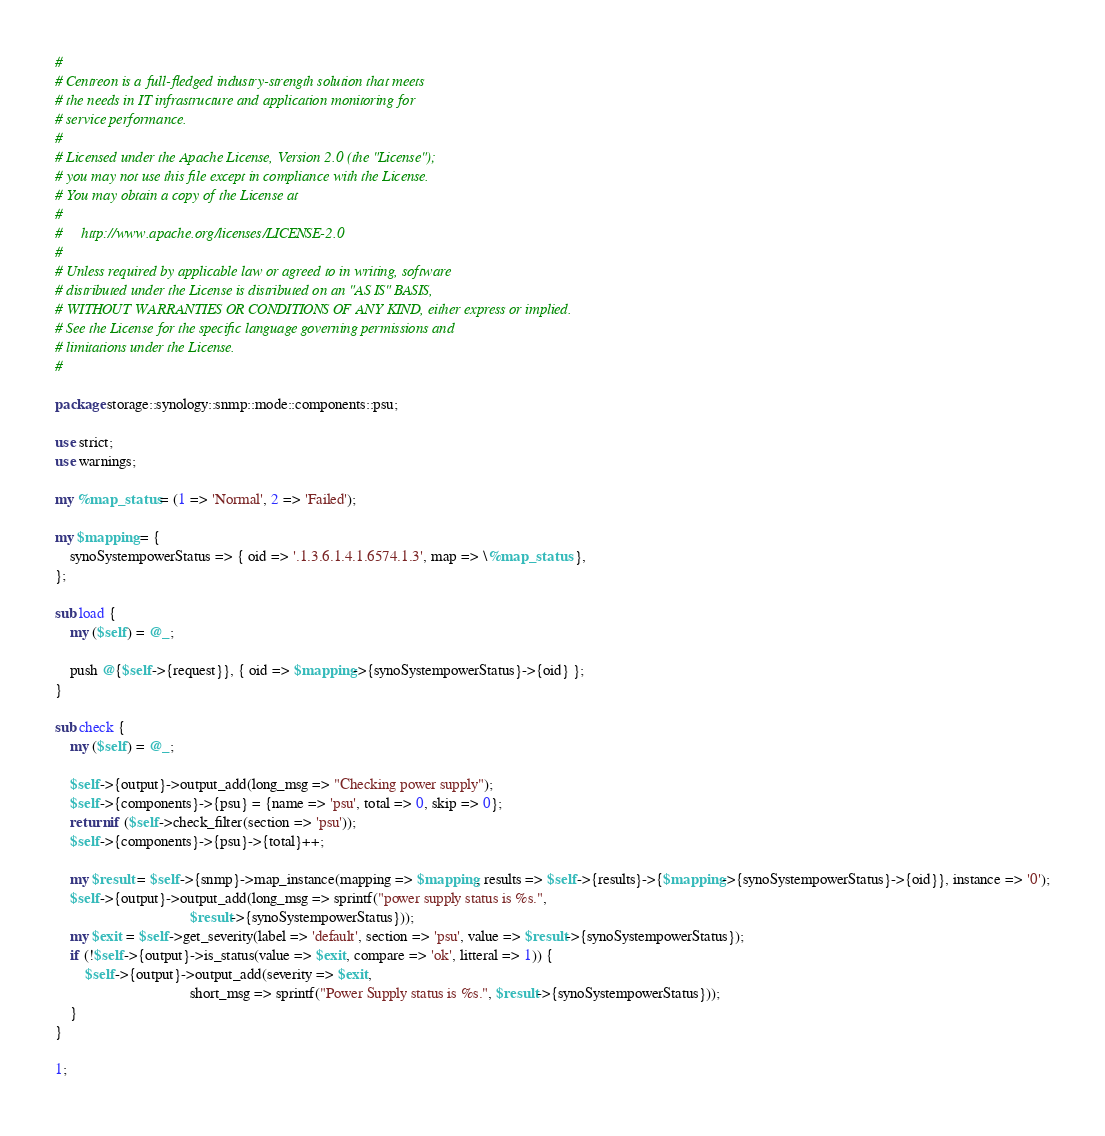Convert code to text. <code><loc_0><loc_0><loc_500><loc_500><_Perl_>#
# Centreon is a full-fledged industry-strength solution that meets
# the needs in IT infrastructure and application monitoring for
# service performance.
#
# Licensed under the Apache License, Version 2.0 (the "License");
# you may not use this file except in compliance with the License.
# You may obtain a copy of the License at
#
#     http://www.apache.org/licenses/LICENSE-2.0
#
# Unless required by applicable law or agreed to in writing, software
# distributed under the License is distributed on an "AS IS" BASIS,
# WITHOUT WARRANTIES OR CONDITIONS OF ANY KIND, either express or implied.
# See the License for the specific language governing permissions and
# limitations under the License.
#

package storage::synology::snmp::mode::components::psu;

use strict;
use warnings;

my %map_status = (1 => 'Normal', 2 => 'Failed');

my $mapping = {
    synoSystempowerStatus => { oid => '.1.3.6.1.4.1.6574.1.3', map => \%map_status  },
};

sub load {
    my ($self) = @_;
    
    push @{$self->{request}}, { oid => $mapping->{synoSystempowerStatus}->{oid} };
}

sub check {
    my ($self) = @_;

    $self->{output}->output_add(long_msg => "Checking power supply");
    $self->{components}->{psu} = {name => 'psu', total => 0, skip => 0};
    return if ($self->check_filter(section => 'psu'));
    $self->{components}->{psu}->{total}++;

    my $result = $self->{snmp}->map_instance(mapping => $mapping, results => $self->{results}->{$mapping->{synoSystempowerStatus}->{oid}}, instance => '0');
    $self->{output}->output_add(long_msg => sprintf("power supply status is %s.",
                                    $result->{synoSystempowerStatus}));
    my $exit = $self->get_severity(label => 'default', section => 'psu', value => $result->{synoSystempowerStatus});
    if (!$self->{output}->is_status(value => $exit, compare => 'ok', litteral => 1)) {
        $self->{output}->output_add(severity => $exit,
                                    short_msg => sprintf("Power Supply status is %s.", $result->{synoSystempowerStatus}));
    }
}

1;</code> 